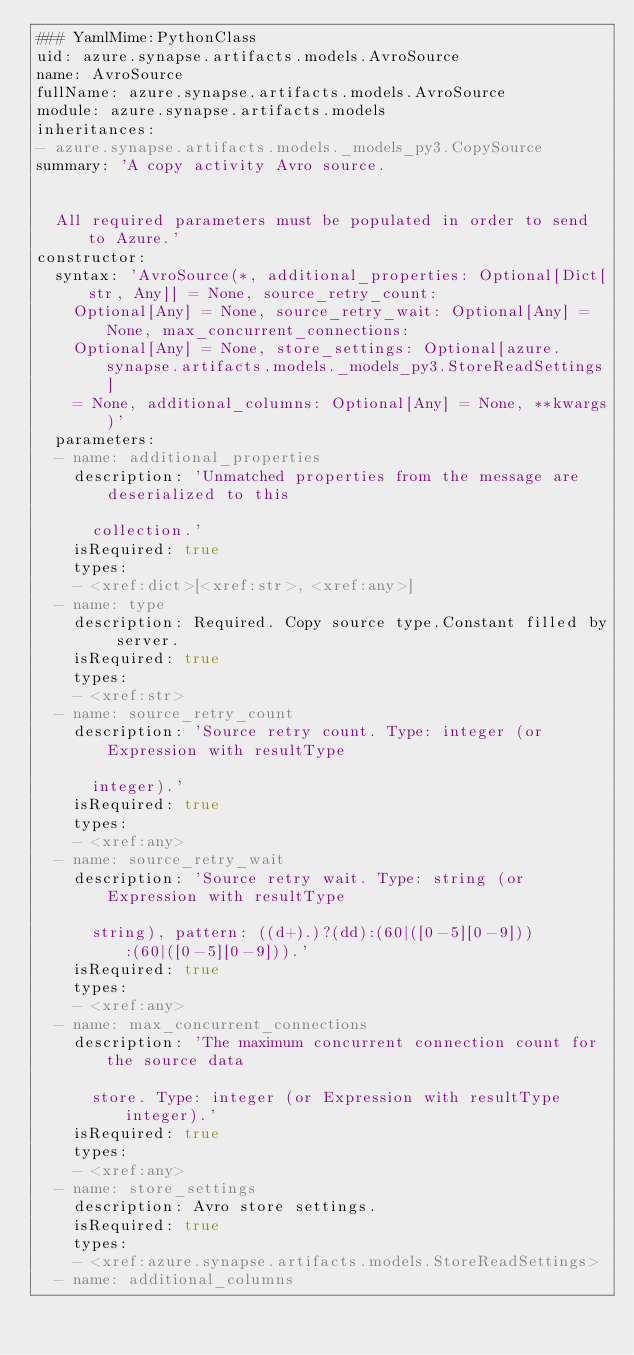<code> <loc_0><loc_0><loc_500><loc_500><_YAML_>### YamlMime:PythonClass
uid: azure.synapse.artifacts.models.AvroSource
name: AvroSource
fullName: azure.synapse.artifacts.models.AvroSource
module: azure.synapse.artifacts.models
inheritances:
- azure.synapse.artifacts.models._models_py3.CopySource
summary: 'A copy activity Avro source.


  All required parameters must be populated in order to send to Azure.'
constructor:
  syntax: 'AvroSource(*, additional_properties: Optional[Dict[str, Any]] = None, source_retry_count:
    Optional[Any] = None, source_retry_wait: Optional[Any] = None, max_concurrent_connections:
    Optional[Any] = None, store_settings: Optional[azure.synapse.artifacts.models._models_py3.StoreReadSettings]
    = None, additional_columns: Optional[Any] = None, **kwargs)'
  parameters:
  - name: additional_properties
    description: 'Unmatched properties from the message are deserialized to this

      collection.'
    isRequired: true
    types:
    - <xref:dict>[<xref:str>, <xref:any>]
  - name: type
    description: Required. Copy source type.Constant filled by server.
    isRequired: true
    types:
    - <xref:str>
  - name: source_retry_count
    description: 'Source retry count. Type: integer (or Expression with resultType

      integer).'
    isRequired: true
    types:
    - <xref:any>
  - name: source_retry_wait
    description: 'Source retry wait. Type: string (or Expression with resultType

      string), pattern: ((d+).)?(dd):(60|([0-5][0-9])):(60|([0-5][0-9])).'
    isRequired: true
    types:
    - <xref:any>
  - name: max_concurrent_connections
    description: 'The maximum concurrent connection count for the source data

      store. Type: integer (or Expression with resultType integer).'
    isRequired: true
    types:
    - <xref:any>
  - name: store_settings
    description: Avro store settings.
    isRequired: true
    types:
    - <xref:azure.synapse.artifacts.models.StoreReadSettings>
  - name: additional_columns</code> 